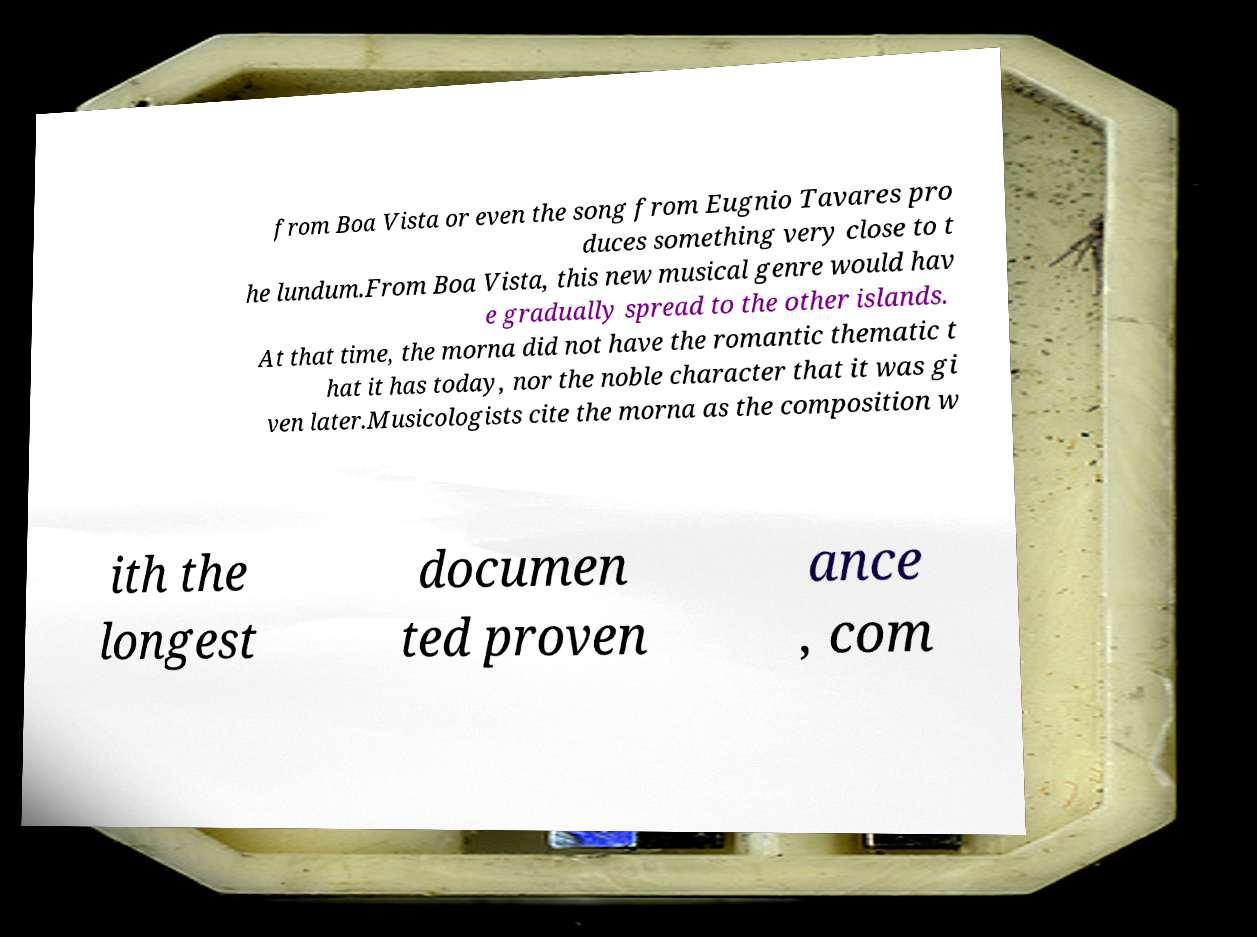Please identify and transcribe the text found in this image. from Boa Vista or even the song from Eugnio Tavares pro duces something very close to t he lundum.From Boa Vista, this new musical genre would hav e gradually spread to the other islands. At that time, the morna did not have the romantic thematic t hat it has today, nor the noble character that it was gi ven later.Musicologists cite the morna as the composition w ith the longest documen ted proven ance , com 